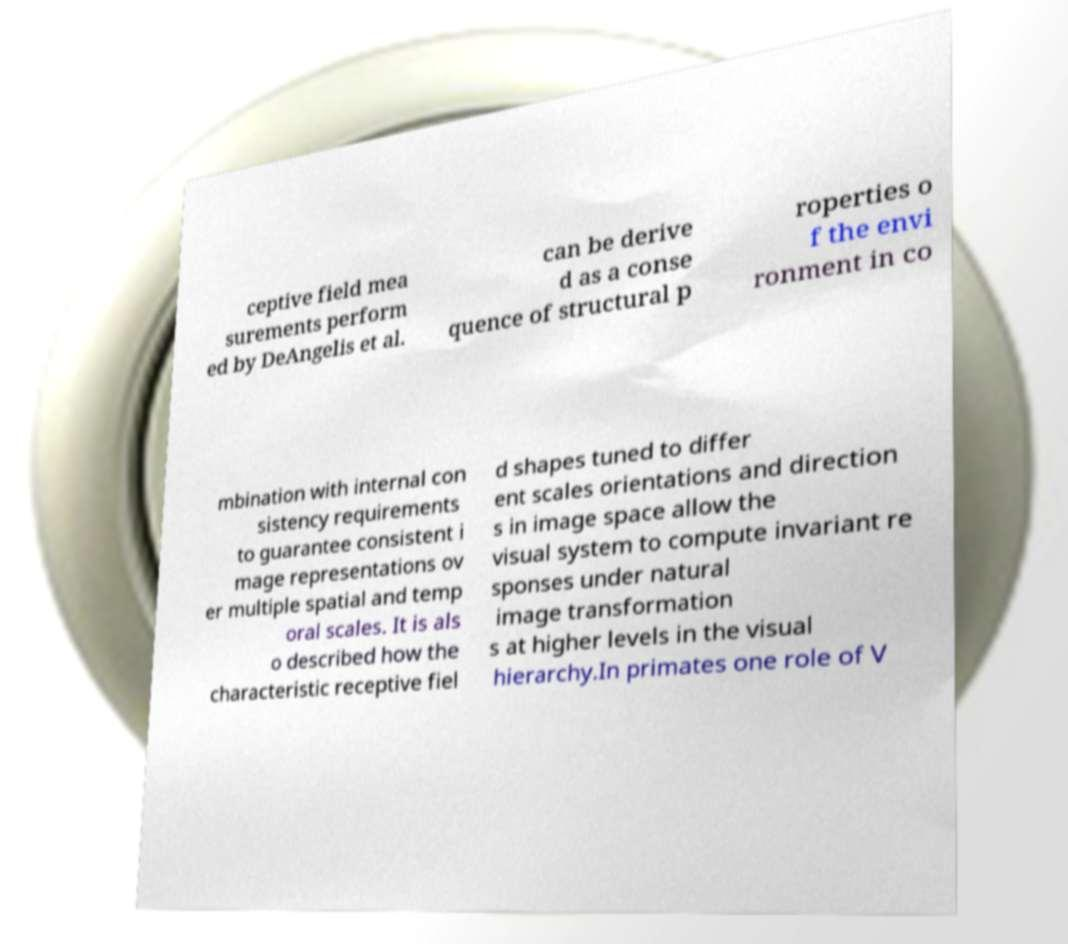Can you read and provide the text displayed in the image?This photo seems to have some interesting text. Can you extract and type it out for me? ceptive field mea surements perform ed by DeAngelis et al. can be derive d as a conse quence of structural p roperties o f the envi ronment in co mbination with internal con sistency requirements to guarantee consistent i mage representations ov er multiple spatial and temp oral scales. It is als o described how the characteristic receptive fiel d shapes tuned to differ ent scales orientations and direction s in image space allow the visual system to compute invariant re sponses under natural image transformation s at higher levels in the visual hierarchy.In primates one role of V 